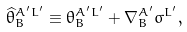Convert formula to latex. <formula><loc_0><loc_0><loc_500><loc_500>\widehat { \theta } _ { B } ^ { A ^ { \prime } L ^ { \prime } } \equiv \theta _ { B } ^ { A ^ { \prime } L ^ { \prime } } + \nabla _ { B } ^ { A ^ { \prime } } \sigma ^ { L ^ { \prime } } ,</formula> 